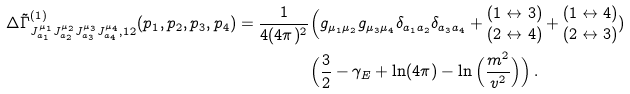<formula> <loc_0><loc_0><loc_500><loc_500>\, \Delta \tilde { \Gamma } ^ { ( 1 ) } _ { J ^ { \mu _ { 1 } } _ { a _ { 1 } } J ^ { \mu _ { 2 } } _ { a _ { 2 } } J ^ { \mu _ { 3 } } _ { a _ { 3 } } J ^ { \mu _ { 4 } } _ { a _ { 4 } } , 1 2 } ( p _ { 1 } , p _ { 2 } , p _ { 3 } , p _ { 4 } ) = \frac { 1 } { 4 ( 4 \pi ) ^ { 2 } } & \Big ( g _ { \mu _ { 1 } \mu _ { 2 } } g _ { \mu _ { 3 } \mu _ { 4 } } \delta _ { a _ { 1 } a _ { 2 } } \delta _ { a _ { 3 } a _ { 4 } } + { \begin{matrix} ( 1 \leftrightarrow 3 ) \\ ( 2 \leftrightarrow 4 ) \end{matrix} } + { \begin{matrix} ( 1 \leftrightarrow 4 ) \\ ( 2 \leftrightarrow 3 ) \end{matrix} } ) \\ & \Big ( \frac { 3 } { 2 } - \gamma _ { E } + \ln ( 4 \pi ) - \ln \Big ( \frac { m ^ { 2 } } { v ^ { 2 } } \Big ) \Big ) \, .</formula> 